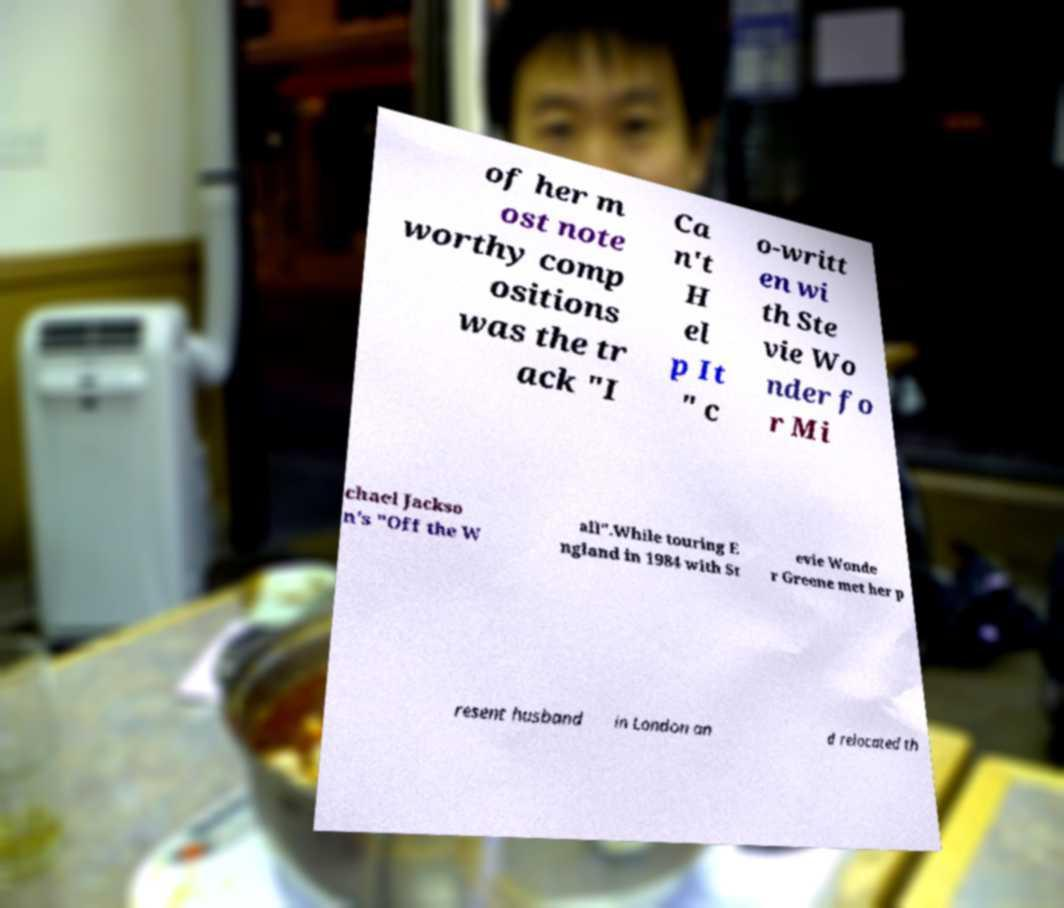Could you extract and type out the text from this image? of her m ost note worthy comp ositions was the tr ack "I Ca n't H el p It " c o-writt en wi th Ste vie Wo nder fo r Mi chael Jackso n's "Off the W all".While touring E ngland in 1984 with St evie Wonde r Greene met her p resent husband in London an d relocated th 